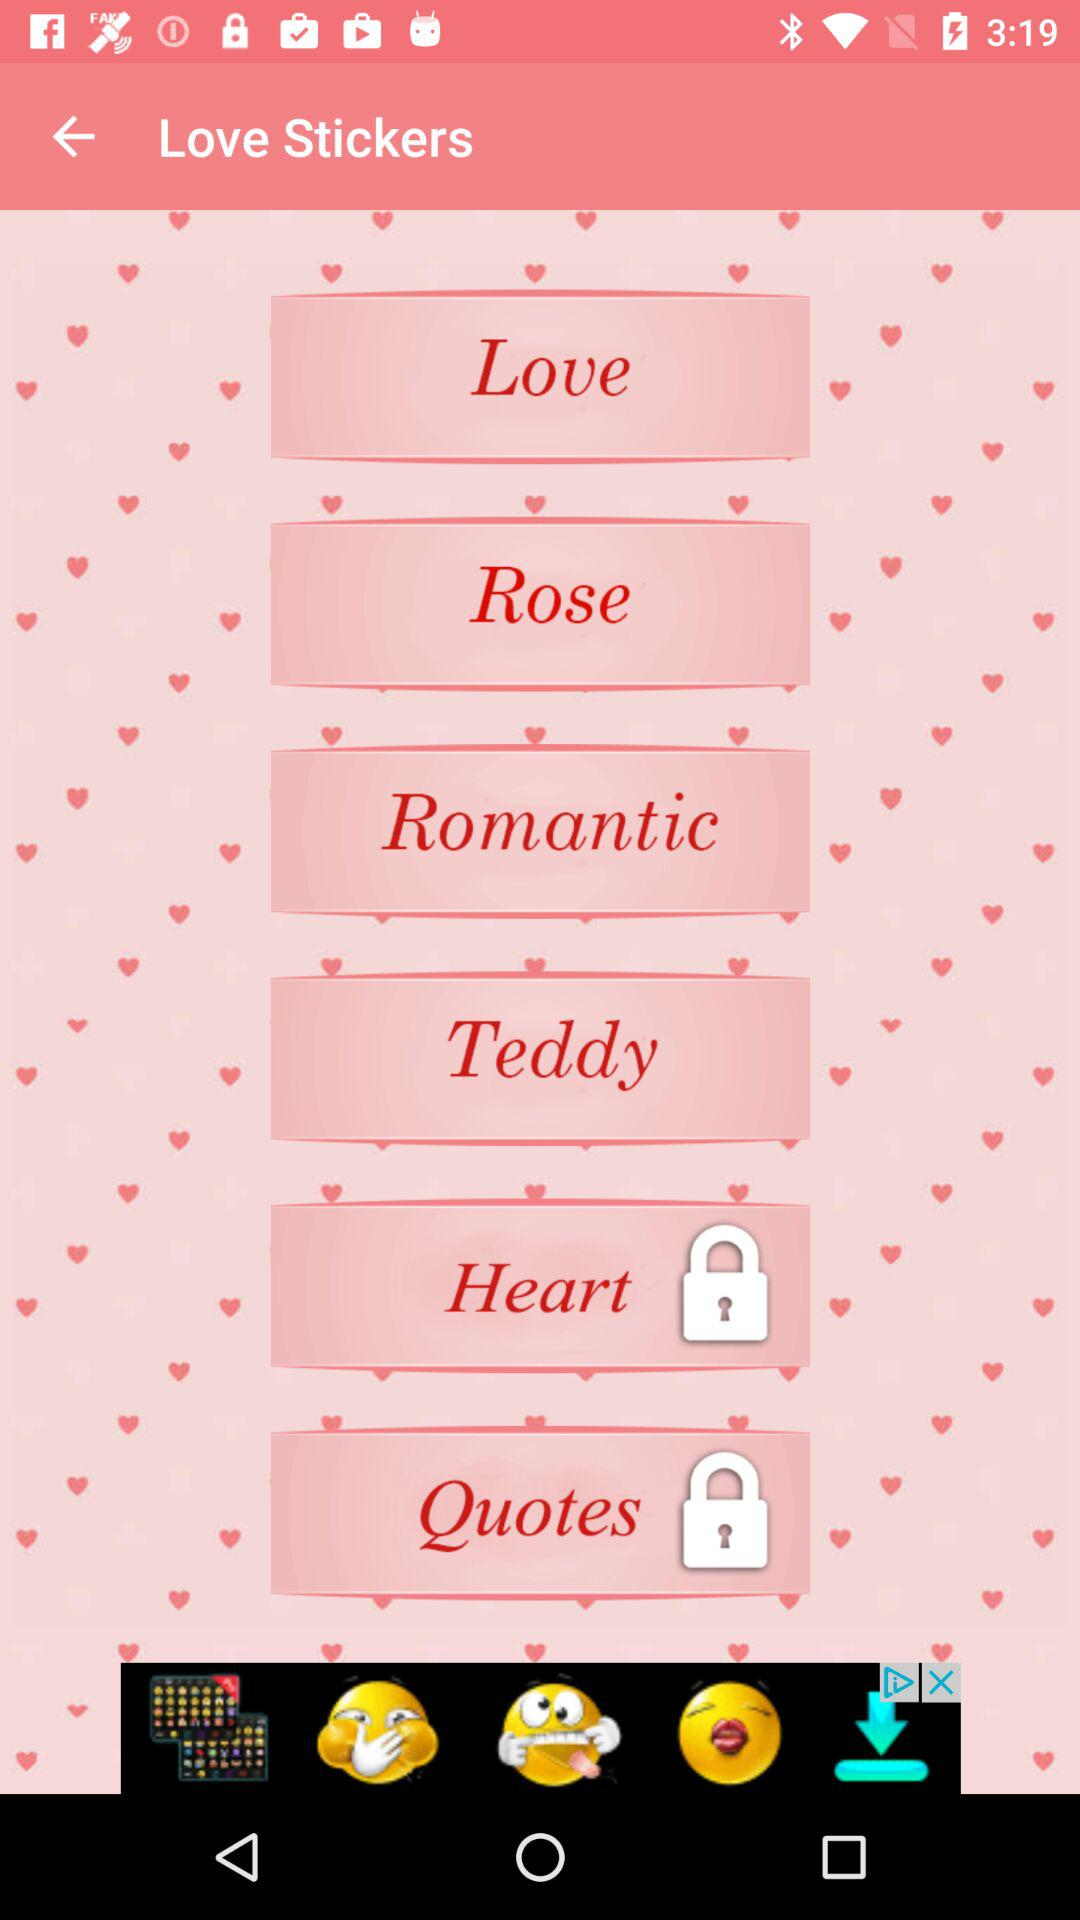How can the "Heart" be unlocked?
When the provided information is insufficient, respond with <no answer>. <no answer> 